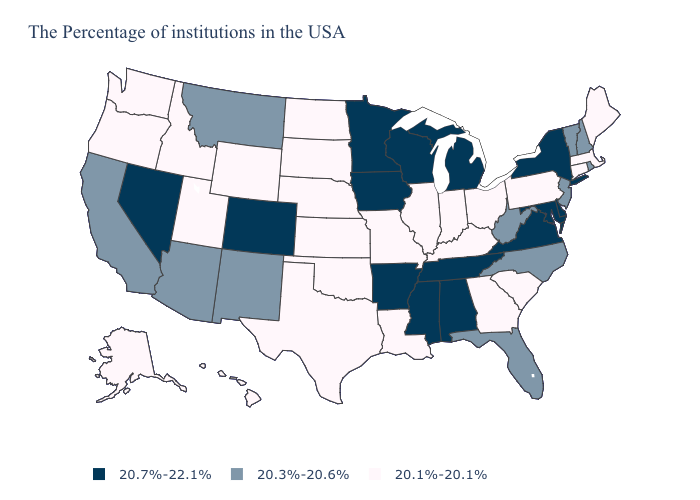Name the states that have a value in the range 20.7%-22.1%?
Quick response, please. New York, Delaware, Maryland, Virginia, Michigan, Alabama, Tennessee, Wisconsin, Mississippi, Arkansas, Minnesota, Iowa, Colorado, Nevada. Name the states that have a value in the range 20.1%-20.1%?
Be succinct. Maine, Massachusetts, Connecticut, Pennsylvania, South Carolina, Ohio, Georgia, Kentucky, Indiana, Illinois, Louisiana, Missouri, Kansas, Nebraska, Oklahoma, Texas, South Dakota, North Dakota, Wyoming, Utah, Idaho, Washington, Oregon, Alaska, Hawaii. Name the states that have a value in the range 20.1%-20.1%?
Answer briefly. Maine, Massachusetts, Connecticut, Pennsylvania, South Carolina, Ohio, Georgia, Kentucky, Indiana, Illinois, Louisiana, Missouri, Kansas, Nebraska, Oklahoma, Texas, South Dakota, North Dakota, Wyoming, Utah, Idaho, Washington, Oregon, Alaska, Hawaii. What is the value of Indiana?
Write a very short answer. 20.1%-20.1%. Name the states that have a value in the range 20.7%-22.1%?
Answer briefly. New York, Delaware, Maryland, Virginia, Michigan, Alabama, Tennessee, Wisconsin, Mississippi, Arkansas, Minnesota, Iowa, Colorado, Nevada. Name the states that have a value in the range 20.1%-20.1%?
Write a very short answer. Maine, Massachusetts, Connecticut, Pennsylvania, South Carolina, Ohio, Georgia, Kentucky, Indiana, Illinois, Louisiana, Missouri, Kansas, Nebraska, Oklahoma, Texas, South Dakota, North Dakota, Wyoming, Utah, Idaho, Washington, Oregon, Alaska, Hawaii. What is the highest value in the Northeast ?
Write a very short answer. 20.7%-22.1%. What is the highest value in the USA?
Short answer required. 20.7%-22.1%. Among the states that border New Mexico , does Colorado have the highest value?
Quick response, please. Yes. Name the states that have a value in the range 20.1%-20.1%?
Answer briefly. Maine, Massachusetts, Connecticut, Pennsylvania, South Carolina, Ohio, Georgia, Kentucky, Indiana, Illinois, Louisiana, Missouri, Kansas, Nebraska, Oklahoma, Texas, South Dakota, North Dakota, Wyoming, Utah, Idaho, Washington, Oregon, Alaska, Hawaii. How many symbols are there in the legend?
Be succinct. 3. Name the states that have a value in the range 20.7%-22.1%?
Be succinct. New York, Delaware, Maryland, Virginia, Michigan, Alabama, Tennessee, Wisconsin, Mississippi, Arkansas, Minnesota, Iowa, Colorado, Nevada. Name the states that have a value in the range 20.3%-20.6%?
Concise answer only. Rhode Island, New Hampshire, Vermont, New Jersey, North Carolina, West Virginia, Florida, New Mexico, Montana, Arizona, California. Does Colorado have the highest value in the West?
Answer briefly. Yes. What is the lowest value in the MidWest?
Be succinct. 20.1%-20.1%. 